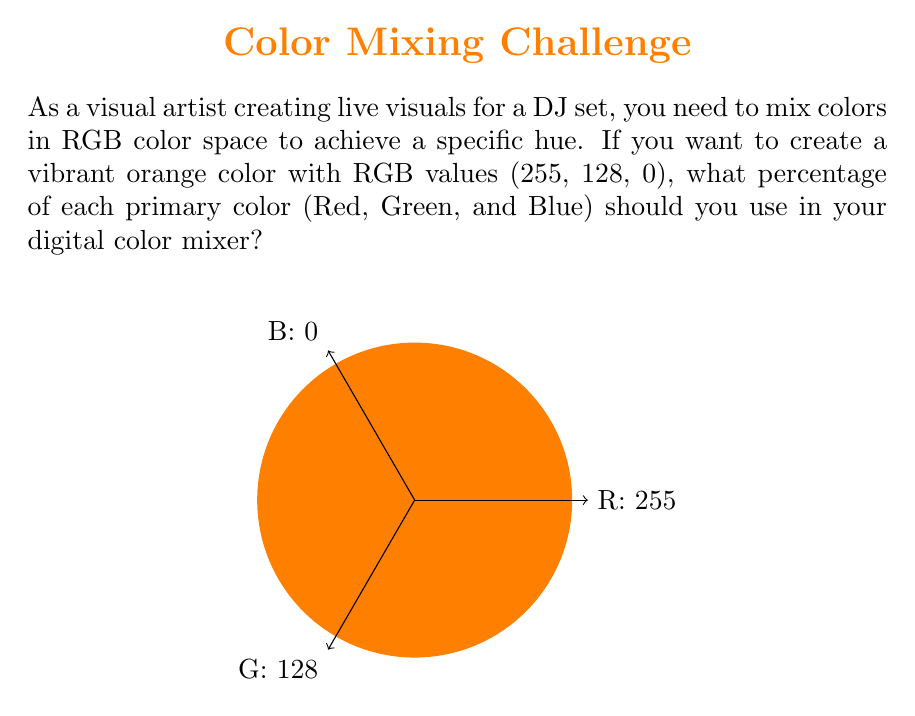Solve this math problem. To calculate the percentage of each primary color in RGB color space, we need to follow these steps:

1) First, let's recall that in RGB color space, each color component ranges from 0 to 255.

2) The given RGB values are (255, 128, 0).

3) To calculate the percentage, we need to divide each component by the maximum possible value (255) and multiply by 100:

   Red: $\frac{255}{255} \times 100\% = 100\%$
   
   Green: $\frac{128}{255} \times 100\% = 50.2\%$
   
   Blue: $\frac{0}{255} \times 100\% = 0\%$

4) We can express these percentages as ratios in their simplest form:

   Red: $\frac{255}{255} = 1$
   
   Green: $\frac{128}{255} = \frac{128}{255} = \frac{1}{2}$ (simplified)
   
   Blue: $\frac{0}{255} = 0$

5) Therefore, the ratio of Red:Green:Blue is 1 : 1/2 : 0

This means you should use 100% of red, 50% of green, and 0% of blue to create the vibrant orange color in your digital color mixer.
Answer: Red:Green:Blue = 1 : 1/2 : 0 